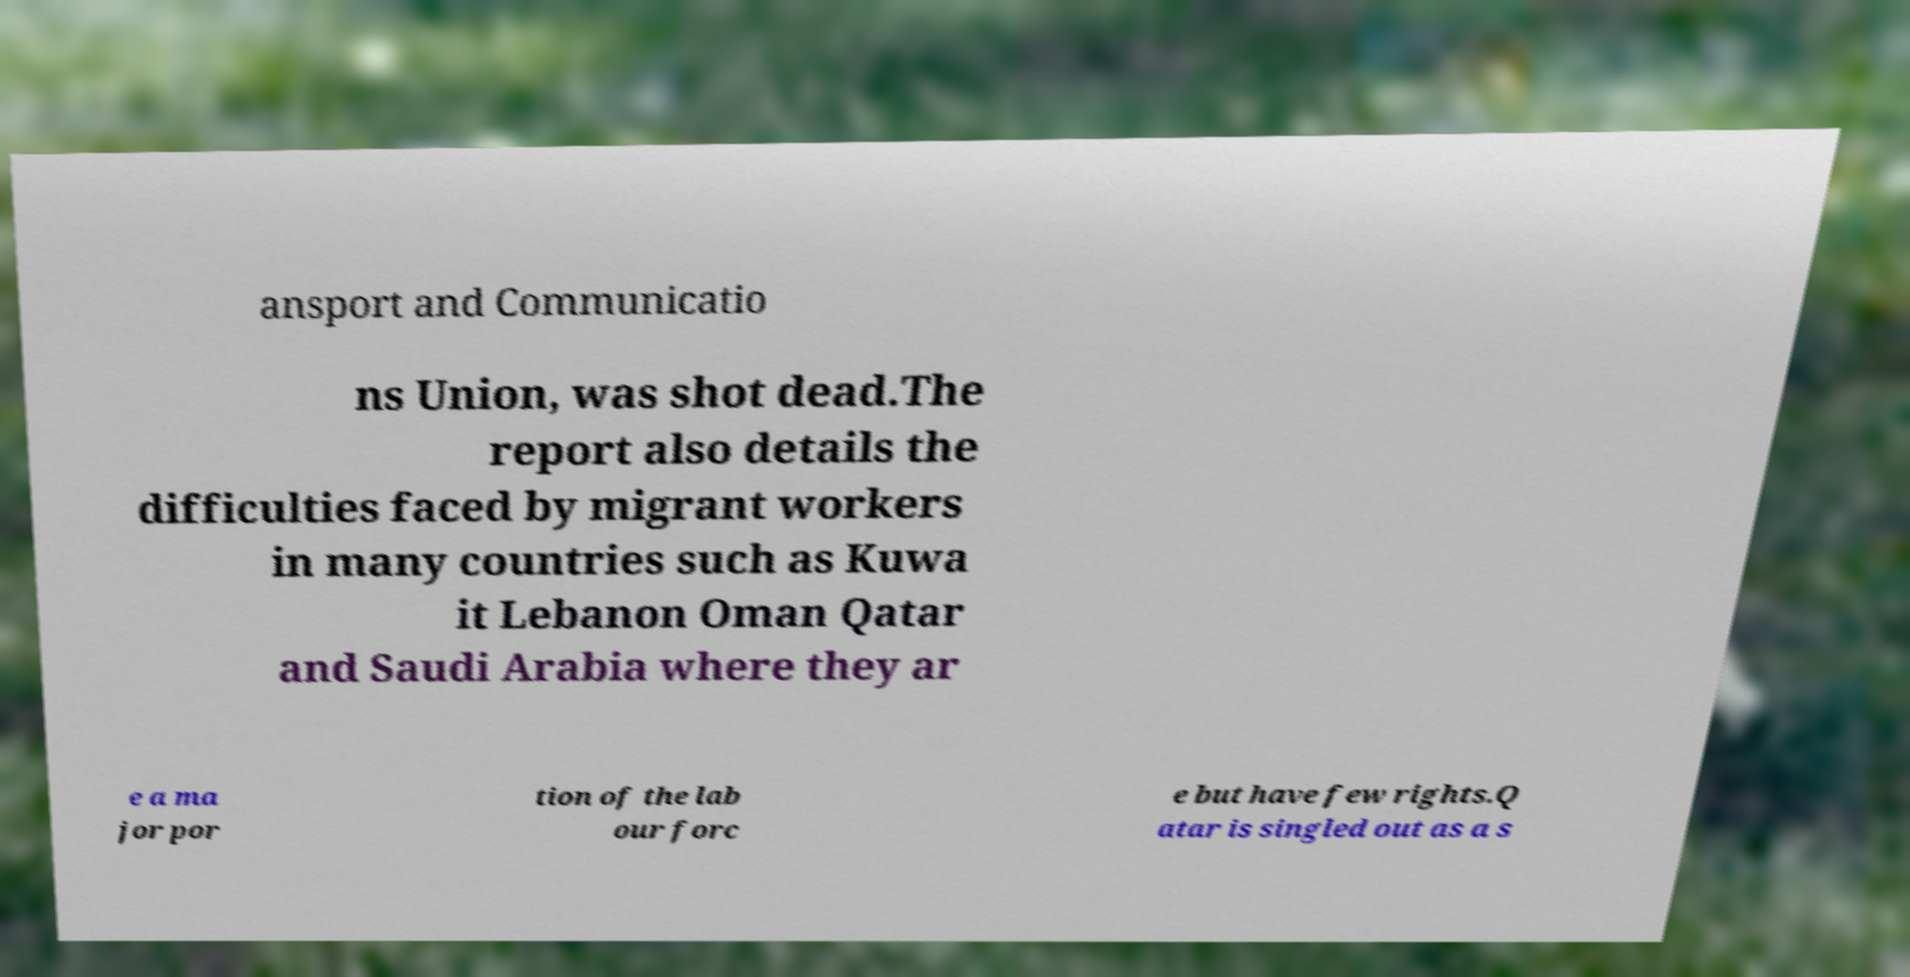Could you assist in decoding the text presented in this image and type it out clearly? ansport and Communicatio ns Union, was shot dead.The report also details the difficulties faced by migrant workers in many countries such as Kuwa it Lebanon Oman Qatar and Saudi Arabia where they ar e a ma jor por tion of the lab our forc e but have few rights.Q atar is singled out as a s 